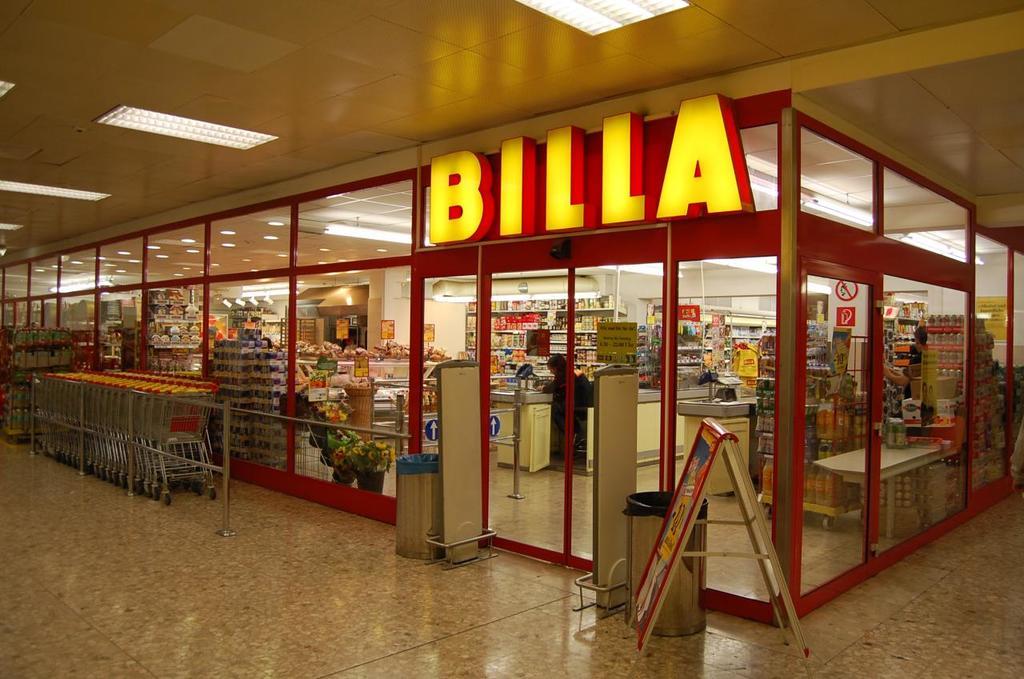What word does the sigh spell?
Provide a short and direct response. Billa. 